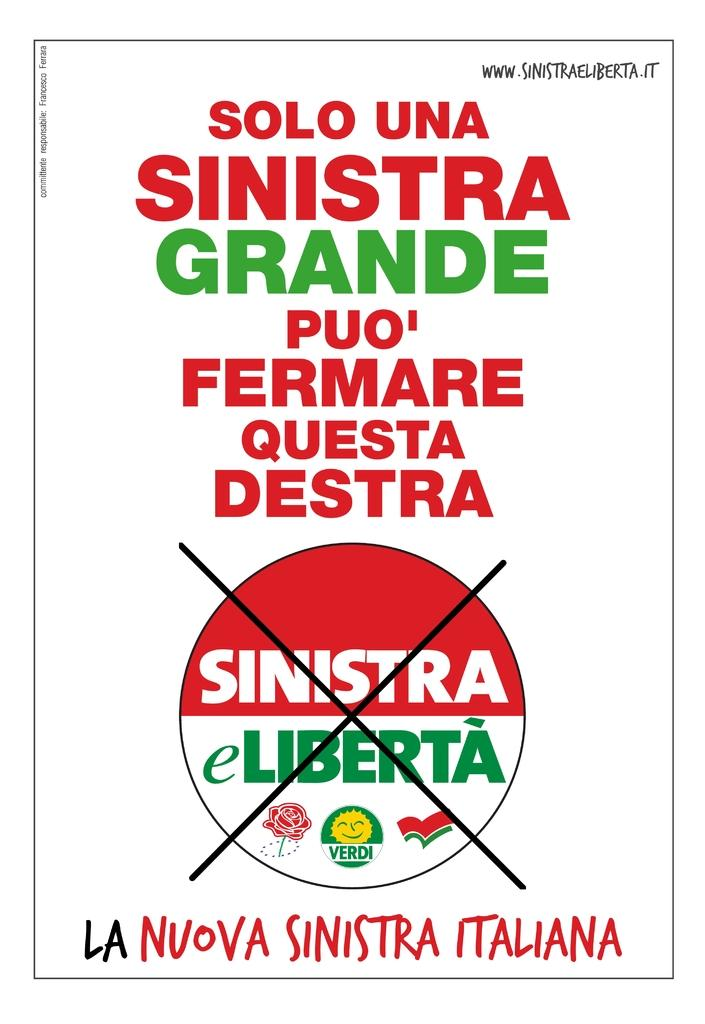Provide a one-sentence caption for the provided image. A poster that says Solo Una Sinistra Grande Puo' on it. 